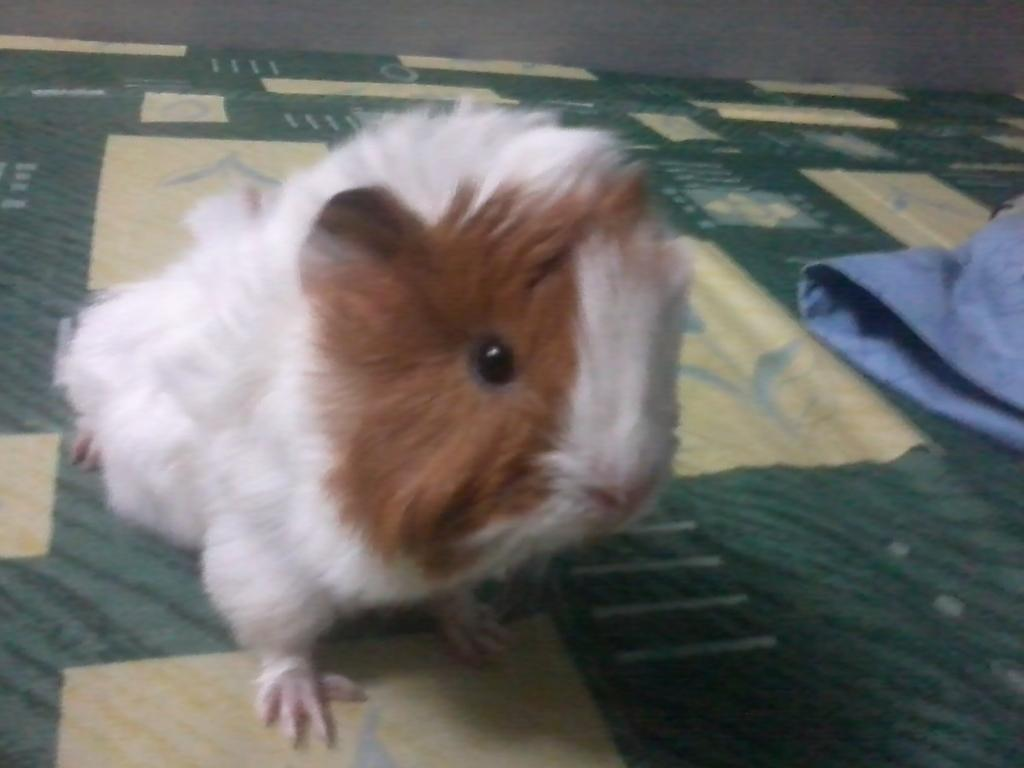What is the main subject of the image? There is an animal on a mat in the image. What else can be seen on the right side of the image? There is a cloth on the right side of the image. What type of background is visible in the image? There is a wall visible at the top of the image. What type of apparatus is being used by the animal in the image? There is no apparatus present in the image; the animal is simply on a mat. What country is the animal from in the image? The image does not provide information about the animal's country of origin. 